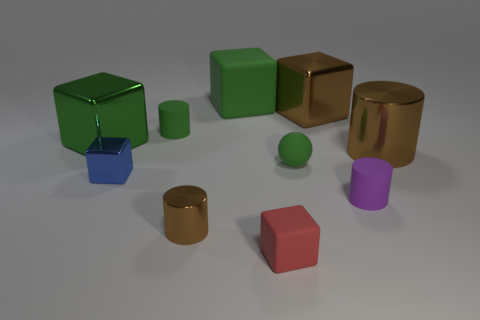How many things are purple things or tiny yellow things?
Your response must be concise. 1. Do the big cube right of the large green rubber cube and the shiny cylinder left of the purple matte thing have the same color?
Ensure brevity in your answer.  Yes. The purple matte object that is the same size as the ball is what shape?
Offer a terse response. Cylinder. How many objects are metal blocks that are to the left of the small purple rubber cylinder or brown shiny cylinders in front of the tiny green ball?
Offer a terse response. 4. Is the number of small red metal spheres less than the number of red objects?
Make the answer very short. Yes. There is a green cylinder that is the same size as the blue block; what is it made of?
Give a very brief answer. Rubber. There is a brown cylinder that is on the right side of the large green matte thing; does it have the same size as the brown metal cylinder to the left of the large rubber block?
Offer a very short reply. No. Is there a large purple ball made of the same material as the blue block?
Ensure brevity in your answer.  No. What number of objects are either large brown shiny things that are in front of the green rubber cylinder or big brown metal cylinders?
Your answer should be compact. 1. Is the cube in front of the tiny blue cube made of the same material as the purple thing?
Your answer should be very brief. Yes. 